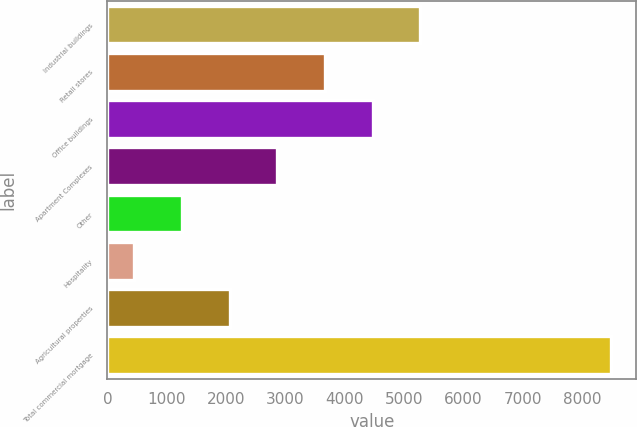Convert chart to OTSL. <chart><loc_0><loc_0><loc_500><loc_500><bar_chart><fcel>Industrial buildings<fcel>Retail stores<fcel>Office buildings<fcel>Apartment Complexes<fcel>Other<fcel>Hospitality<fcel>Agricultural properties<fcel>Total commercial mortgage<nl><fcel>5272.8<fcel>3666.2<fcel>4469.5<fcel>2862.9<fcel>1256.3<fcel>453<fcel>2059.6<fcel>8486<nl></chart> 